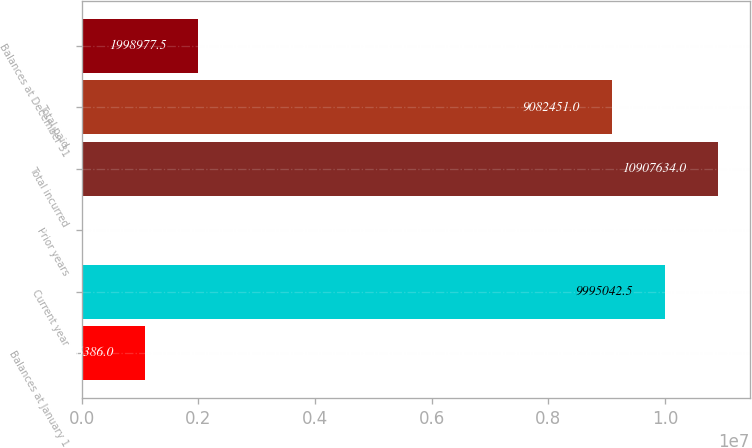<chart> <loc_0><loc_0><loc_500><loc_500><bar_chart><fcel>Balances at January 1<fcel>Current year<fcel>Prior years<fcel>Total incurred<fcel>Total paid<fcel>Balances at December 31<nl><fcel>1.08639e+06<fcel>9.99504e+06<fcel>12281<fcel>1.09076e+07<fcel>9.08245e+06<fcel>1.99898e+06<nl></chart> 